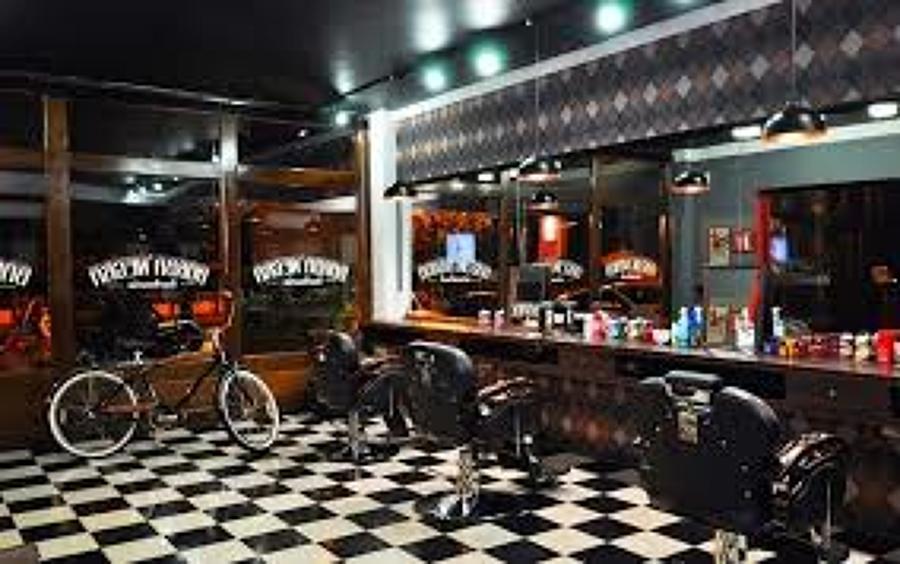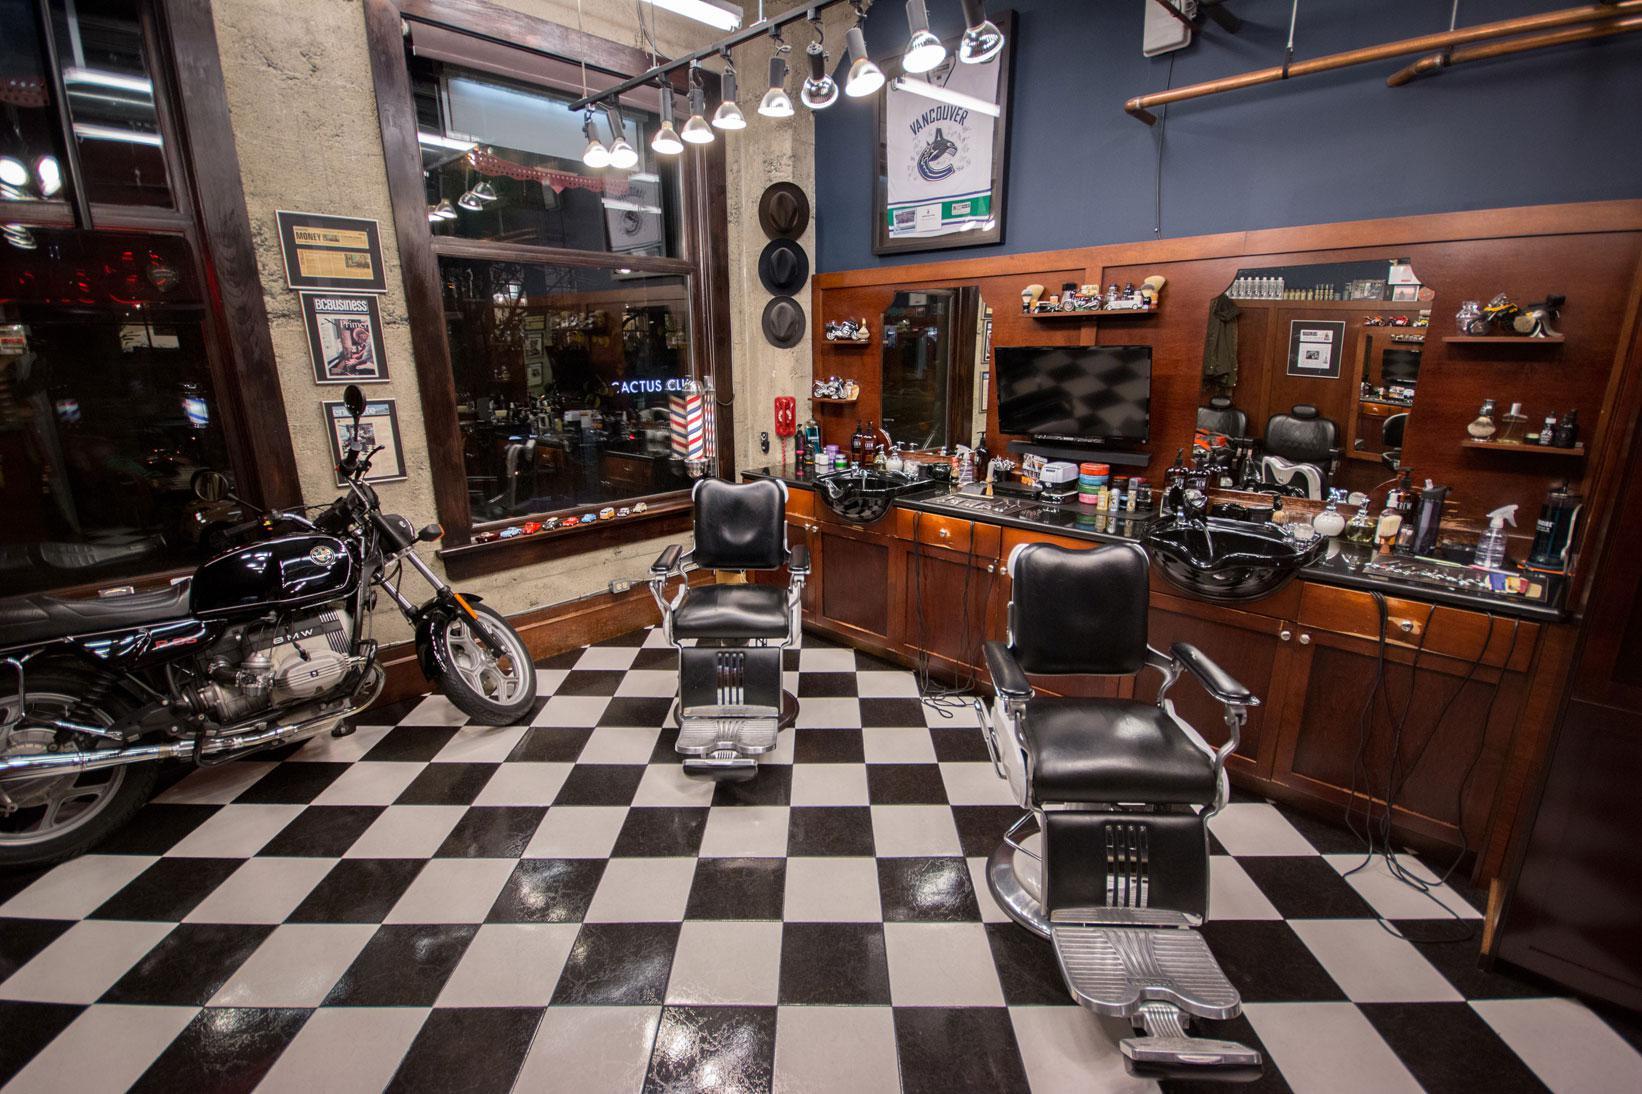The first image is the image on the left, the second image is the image on the right. For the images shown, is this caption "Barbers are cutting their clients' hair." true? Answer yes or no. No. The first image is the image on the left, the second image is the image on the right. Assess this claim about the two images: "An image shows barbers working on clients' hair.". Correct or not? Answer yes or no. No. 